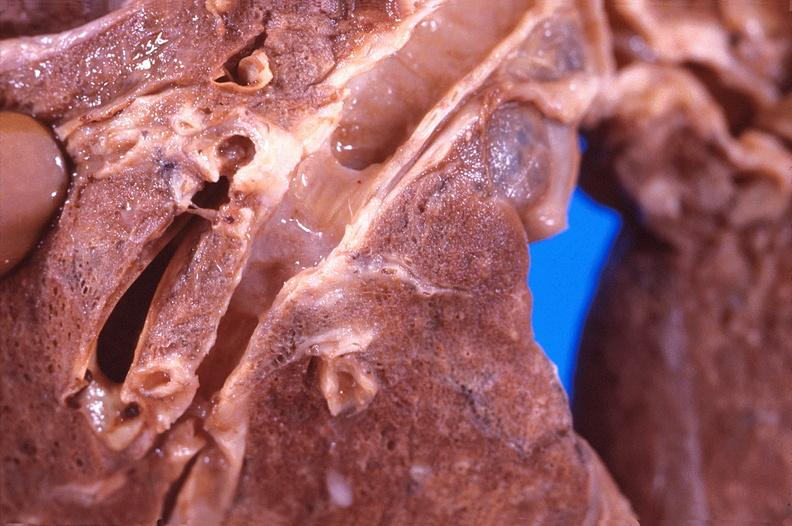what does this image show?
Answer the question using a single word or phrase. Lung 